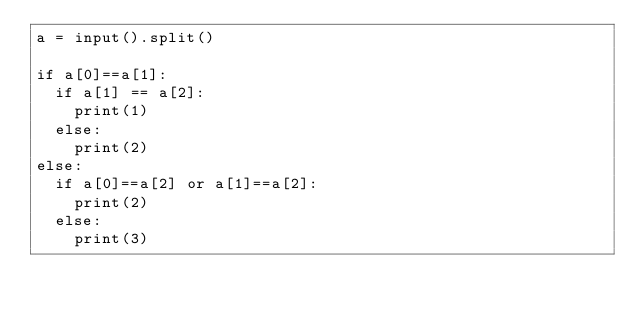<code> <loc_0><loc_0><loc_500><loc_500><_Python_>a = input().split()

if a[0]==a[1]:
  if a[1] == a[2]:
    print(1)
  else:
    print(2)
else:
  if a[0]==a[2] or a[1]==a[2]:
    print(2)
  else:
    print(3)</code> 